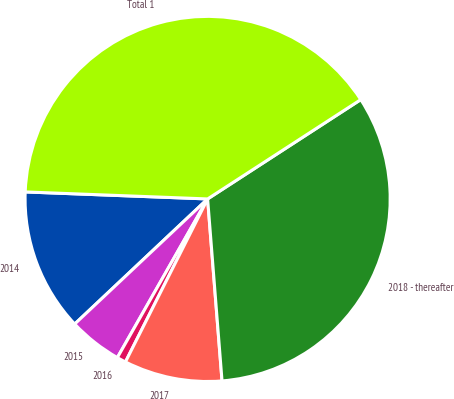Convert chart. <chart><loc_0><loc_0><loc_500><loc_500><pie_chart><fcel>2014<fcel>2015<fcel>2016<fcel>2017<fcel>2018 - thereafter<fcel>Total 1<nl><fcel>12.63%<fcel>4.75%<fcel>0.8%<fcel>8.69%<fcel>32.9%<fcel>40.23%<nl></chart> 